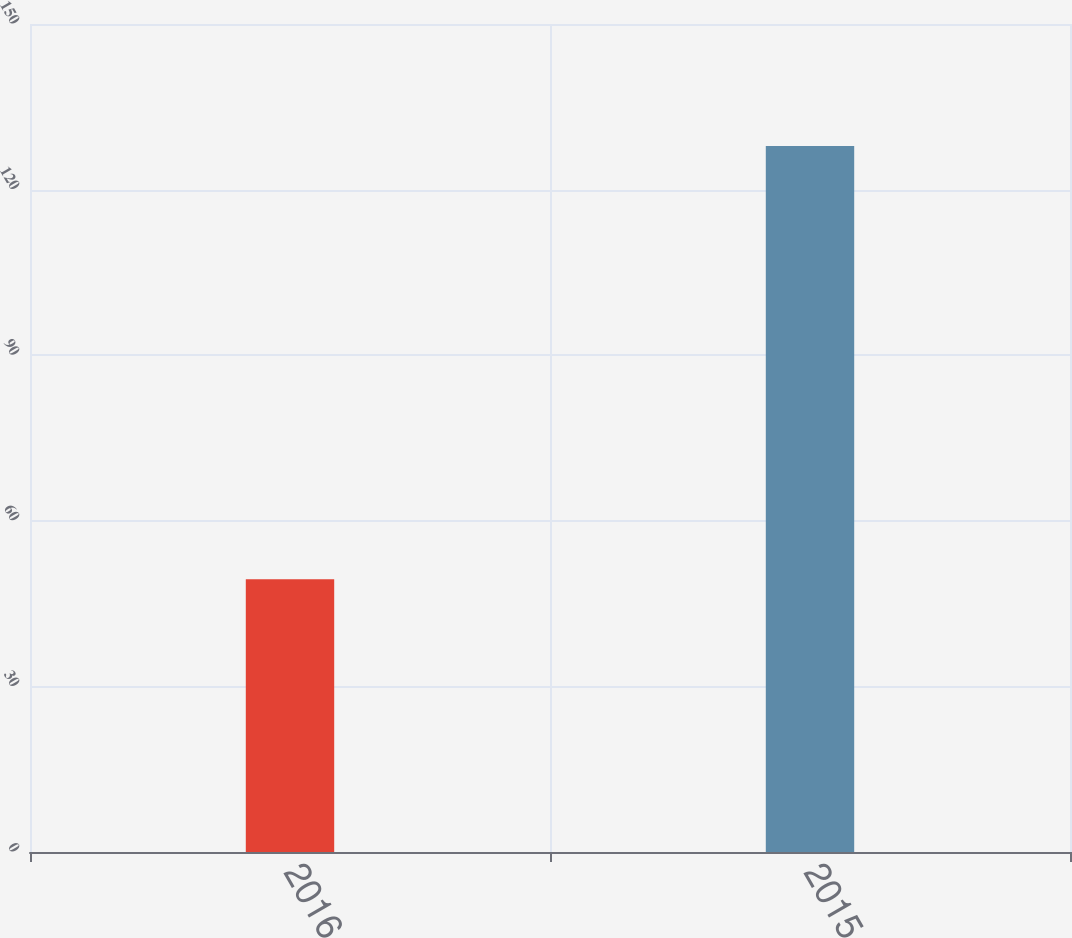<chart> <loc_0><loc_0><loc_500><loc_500><bar_chart><fcel>2016<fcel>2015<nl><fcel>49.4<fcel>127.9<nl></chart> 